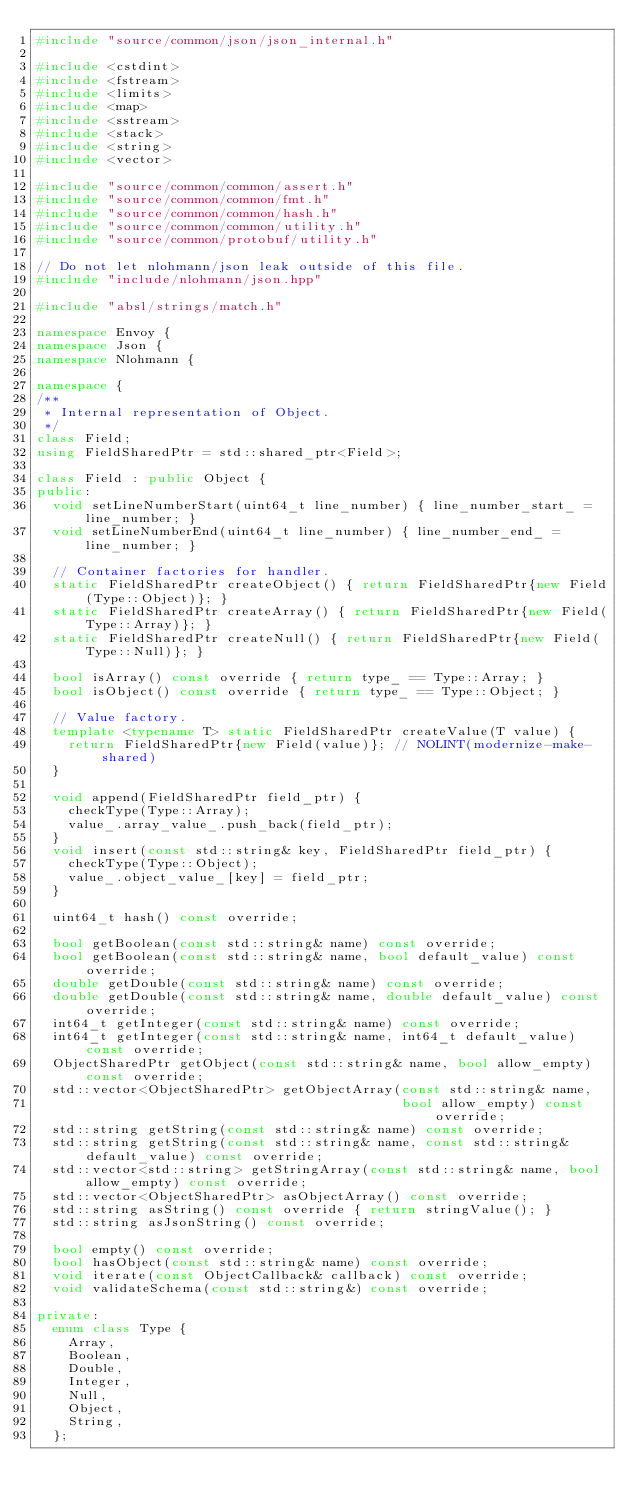<code> <loc_0><loc_0><loc_500><loc_500><_C++_>#include "source/common/json/json_internal.h"

#include <cstdint>
#include <fstream>
#include <limits>
#include <map>
#include <sstream>
#include <stack>
#include <string>
#include <vector>

#include "source/common/common/assert.h"
#include "source/common/common/fmt.h"
#include "source/common/common/hash.h"
#include "source/common/common/utility.h"
#include "source/common/protobuf/utility.h"

// Do not let nlohmann/json leak outside of this file.
#include "include/nlohmann/json.hpp"

#include "absl/strings/match.h"

namespace Envoy {
namespace Json {
namespace Nlohmann {

namespace {
/**
 * Internal representation of Object.
 */
class Field;
using FieldSharedPtr = std::shared_ptr<Field>;

class Field : public Object {
public:
  void setLineNumberStart(uint64_t line_number) { line_number_start_ = line_number; }
  void setLineNumberEnd(uint64_t line_number) { line_number_end_ = line_number; }

  // Container factories for handler.
  static FieldSharedPtr createObject() { return FieldSharedPtr{new Field(Type::Object)}; }
  static FieldSharedPtr createArray() { return FieldSharedPtr{new Field(Type::Array)}; }
  static FieldSharedPtr createNull() { return FieldSharedPtr{new Field(Type::Null)}; }

  bool isArray() const override { return type_ == Type::Array; }
  bool isObject() const override { return type_ == Type::Object; }

  // Value factory.
  template <typename T> static FieldSharedPtr createValue(T value) {
    return FieldSharedPtr{new Field(value)}; // NOLINT(modernize-make-shared)
  }

  void append(FieldSharedPtr field_ptr) {
    checkType(Type::Array);
    value_.array_value_.push_back(field_ptr);
  }
  void insert(const std::string& key, FieldSharedPtr field_ptr) {
    checkType(Type::Object);
    value_.object_value_[key] = field_ptr;
  }

  uint64_t hash() const override;

  bool getBoolean(const std::string& name) const override;
  bool getBoolean(const std::string& name, bool default_value) const override;
  double getDouble(const std::string& name) const override;
  double getDouble(const std::string& name, double default_value) const override;
  int64_t getInteger(const std::string& name) const override;
  int64_t getInteger(const std::string& name, int64_t default_value) const override;
  ObjectSharedPtr getObject(const std::string& name, bool allow_empty) const override;
  std::vector<ObjectSharedPtr> getObjectArray(const std::string& name,
                                              bool allow_empty) const override;
  std::string getString(const std::string& name) const override;
  std::string getString(const std::string& name, const std::string& default_value) const override;
  std::vector<std::string> getStringArray(const std::string& name, bool allow_empty) const override;
  std::vector<ObjectSharedPtr> asObjectArray() const override;
  std::string asString() const override { return stringValue(); }
  std::string asJsonString() const override;

  bool empty() const override;
  bool hasObject(const std::string& name) const override;
  void iterate(const ObjectCallback& callback) const override;
  void validateSchema(const std::string&) const override;

private:
  enum class Type {
    Array,
    Boolean,
    Double,
    Integer,
    Null,
    Object,
    String,
  };</code> 